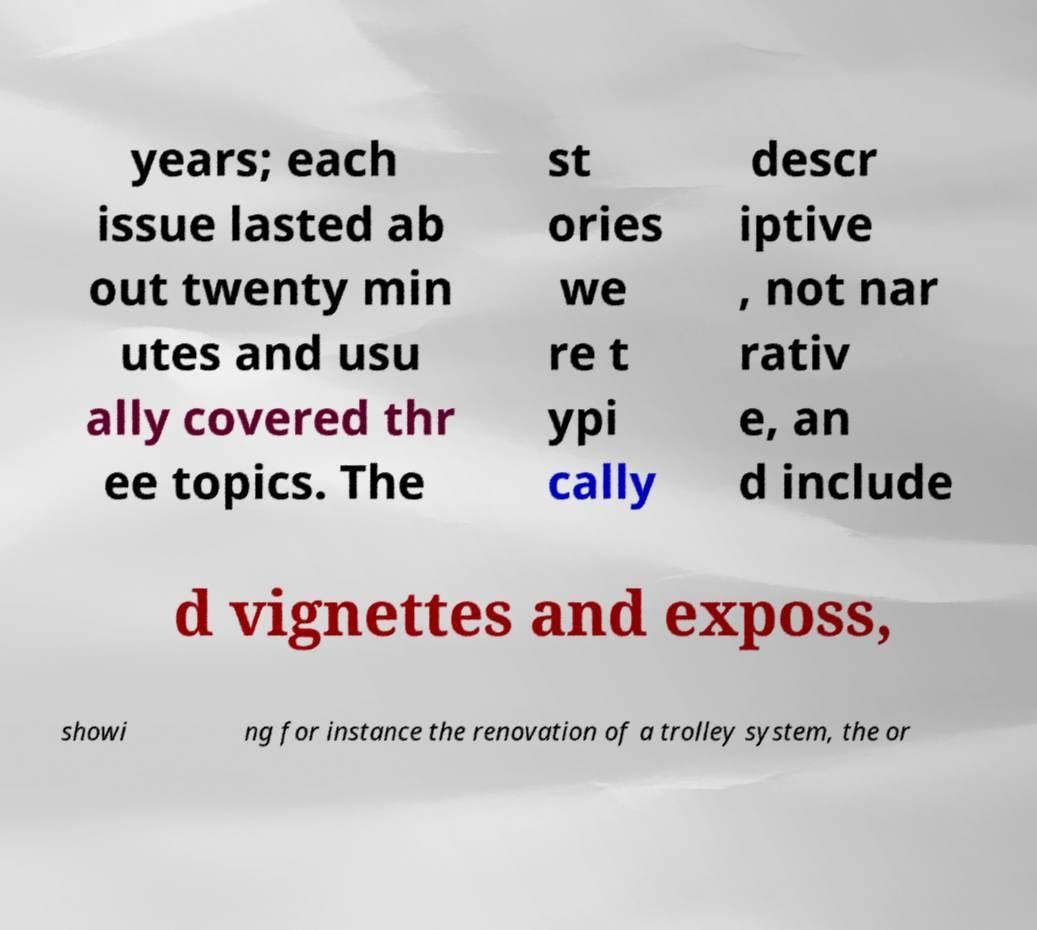Please identify and transcribe the text found in this image. years; each issue lasted ab out twenty min utes and usu ally covered thr ee topics. The st ories we re t ypi cally descr iptive , not nar rativ e, an d include d vignettes and exposs, showi ng for instance the renovation of a trolley system, the or 